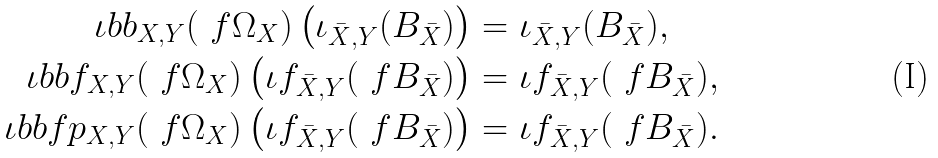<formula> <loc_0><loc_0><loc_500><loc_500>\iota b b _ { X , Y } ( \ f { \Omega } _ { X } ) \left ( \iota _ { \bar { X } , Y } ( B _ { \bar { X } } ) \right ) & = \iota _ { \bar { X } , Y } ( B _ { \bar { X } } ) , \\ \iota b b f _ { X , Y } ( \ f { \Omega } _ { X } ) \left ( \iota f _ { \bar { X } , Y } ( \ f { B } _ { \bar { X } } ) \right ) & = \iota f _ { \bar { X } , Y } ( \ f { B } _ { \bar { X } } ) , \\ \iota b b f p _ { X , Y } ( \ f { \Omega } _ { X } ) \left ( \iota f _ { \bar { X } , Y } ( \ f { B } _ { \bar { X } } ) \right ) & = \iota f _ { \bar { X } , Y } ( \ f { B } _ { \bar { X } } ) .</formula> 